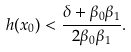Convert formula to latex. <formula><loc_0><loc_0><loc_500><loc_500>h ( x _ { 0 } ) < \frac { \delta + \beta _ { 0 } \beta _ { 1 } } { 2 \beta _ { 0 } \beta _ { 1 } } .</formula> 